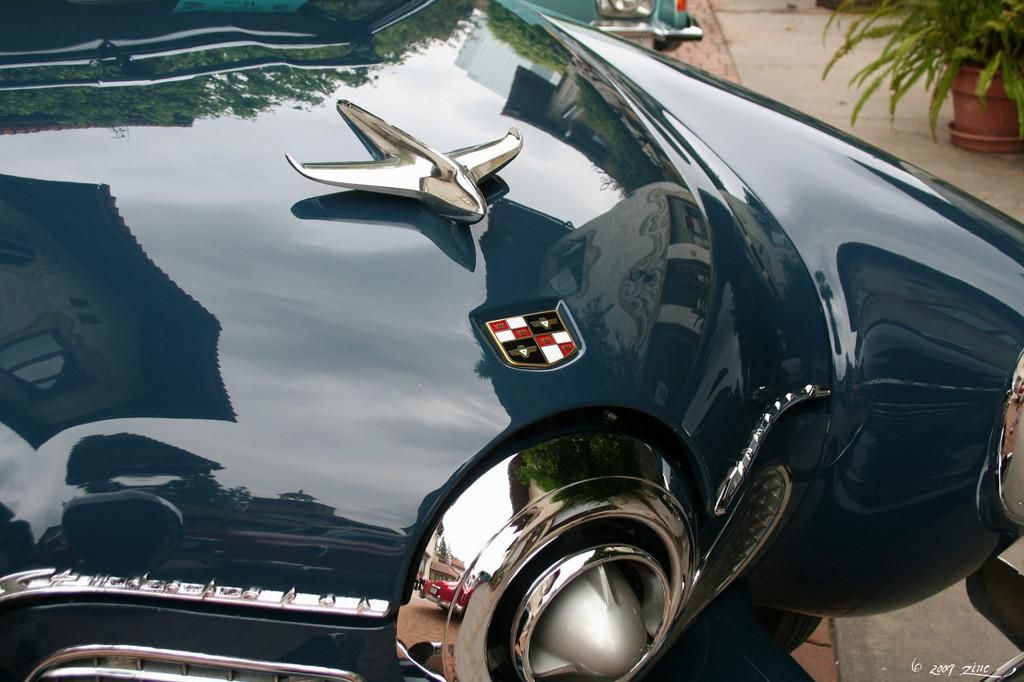What part of a car can be seen in the image? The front part of a car is visible in the image. Are there any distinguishing features on the car? Yes, there are two logos on the car. What type of plant is present in the background of the image? There is a house plant in a pot in the background. Where is the house plant located? The house plant is on the floor in the background. What else can be seen in the background of the image? There is a truncated vehicle in the background. How does the car experience thrill in the image? The car does not experience thrill in the image; it is a static object. What is the digestion process of the house plant in the image? There is no digestion process to describe for the house plant in the image, as it is a plant and not an animal. 